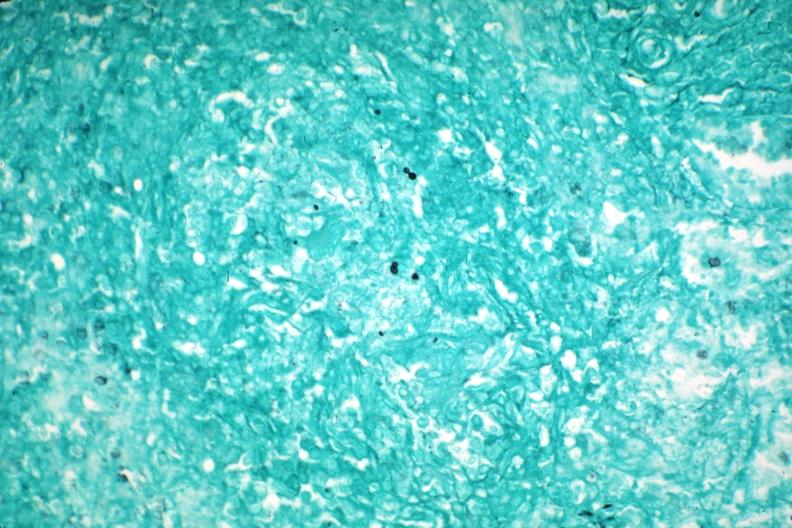does this image show gms granuloma due to pneumocystis aids case?
Answer the question using a single word or phrase. Yes 